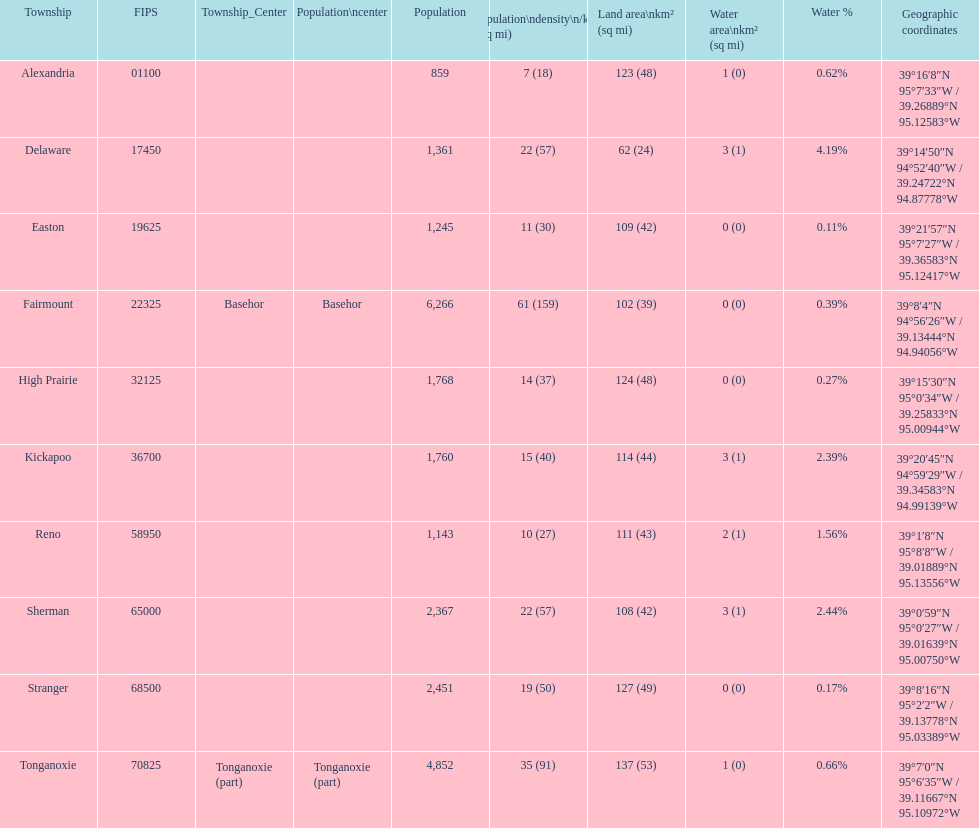Was delaware's land area above or below 45 square miles? Above. 